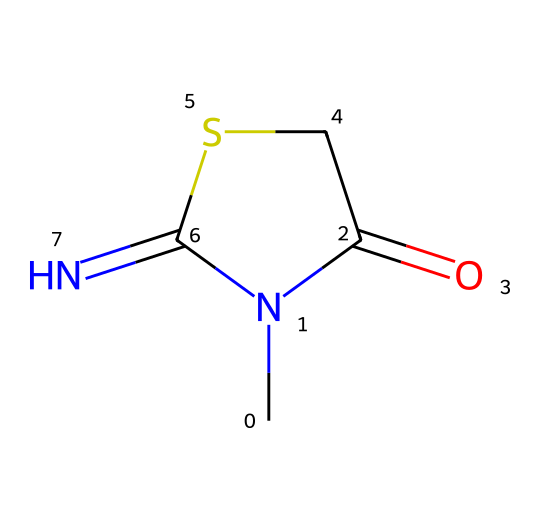What is the molecular formula of methylisothiazolinone? To derive the molecular formula from the SMILES representation, count the atoms represented in the chemical structure. The breakdown shows that there are one carbon atom from "C", two nitrogen atoms from "N", one oxygen atom from "O", one sulfur atom from "S", and three hydrogen atoms implied by the structure. Combining these gives the formula C4H5N2OS.
Answer: C4H5N2OS How many rings are present in the structure? From the SMILES notation, the "C" is linked to a "S" in the cyclic portion indicated by "N1", which shows that there is one ring in the structure. Therefore, the count of the cyclic nature indicates the presence of one ring.
Answer: 1 What types of elements are present in methylisothiazolinone? Analyzing the SMILES, we find carbon (C), hydrogen (H), nitrogen (N), oxygen (O), and sulfur (S). These indicate that the chemical is composed of these five types of elements.
Answer: Carbon, Hydrogen, Nitrogen, Oxygen, Sulfur Is methylisothiazolinone an organic compound? Yes, methylisothiazolinone contains carbon atoms, which are a defining feature of organic compounds. In addition, it has a heterocyclic structure with nitrogen and sulfur, supporting its classification as an organic compound.
Answer: Yes What is the role of methylisothiazolinone in household cleaning products? Generally, methylisothiazolinone serves as a preservative, helping to prevent microbial growth, prolonging the shelf life of cleaning products, and maintaining their effectiveness.
Answer: Preservative Does methylisothiazolinone have any toxicity concerns? The structure's associated risks suggest that while it is effective as a preservative, it may cause skin sensitization and allergic reactions under certain conditions. Thus, it is considered to have potential toxicity in specific contexts.
Answer: Yes 